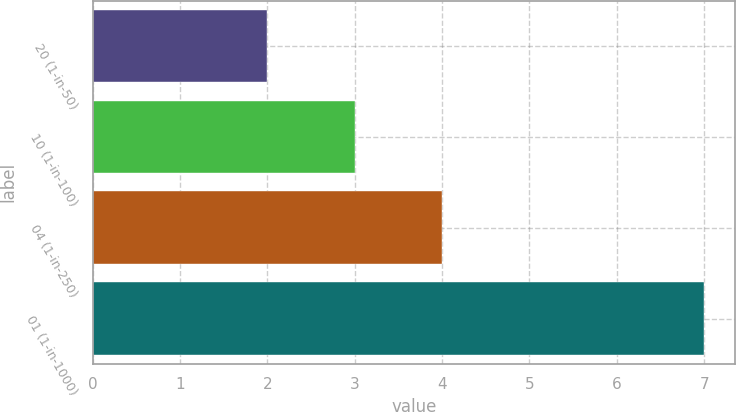<chart> <loc_0><loc_0><loc_500><loc_500><bar_chart><fcel>20 (1-in-50)<fcel>10 (1-in-100)<fcel>04 (1-in-250)<fcel>01 (1-in-1000)<nl><fcel>2<fcel>3<fcel>4<fcel>7<nl></chart> 